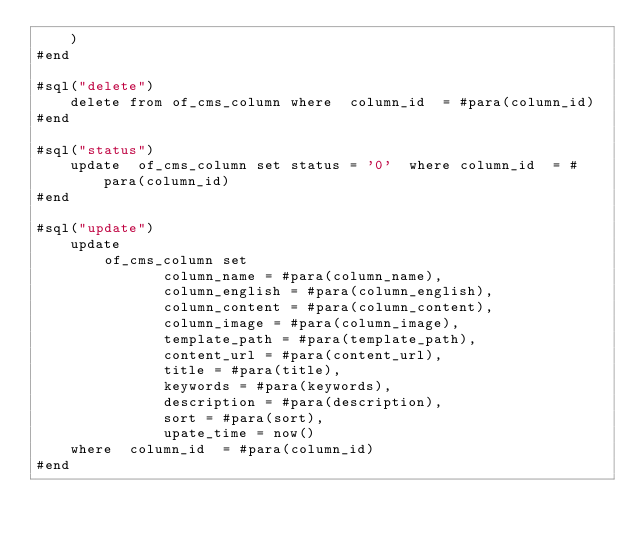<code> <loc_0><loc_0><loc_500><loc_500><_SQL_>	)
#end

#sql("delete")
	delete from of_cms_column where  column_id  = #para(column_id)
#end

#sql("status")
	update  of_cms_column set status = '0'  where column_id  = #para(column_id)
#end

#sql("update")
	update  
		of_cms_column set 
			   column_name = #para(column_name),
			   column_english = #para(column_english), 
			   column_content = #para(column_content),
			   column_image = #para(column_image), 
			   template_path = #para(template_path), 
			   content_url = #para(content_url), 
			   title = #para(title), 
			   keywords = #para(keywords), 
			   description = #para(description), 
			   sort = #para(sort),
			   upate_time = now()
	where  column_id  = #para(column_id)
#end
 
</code> 